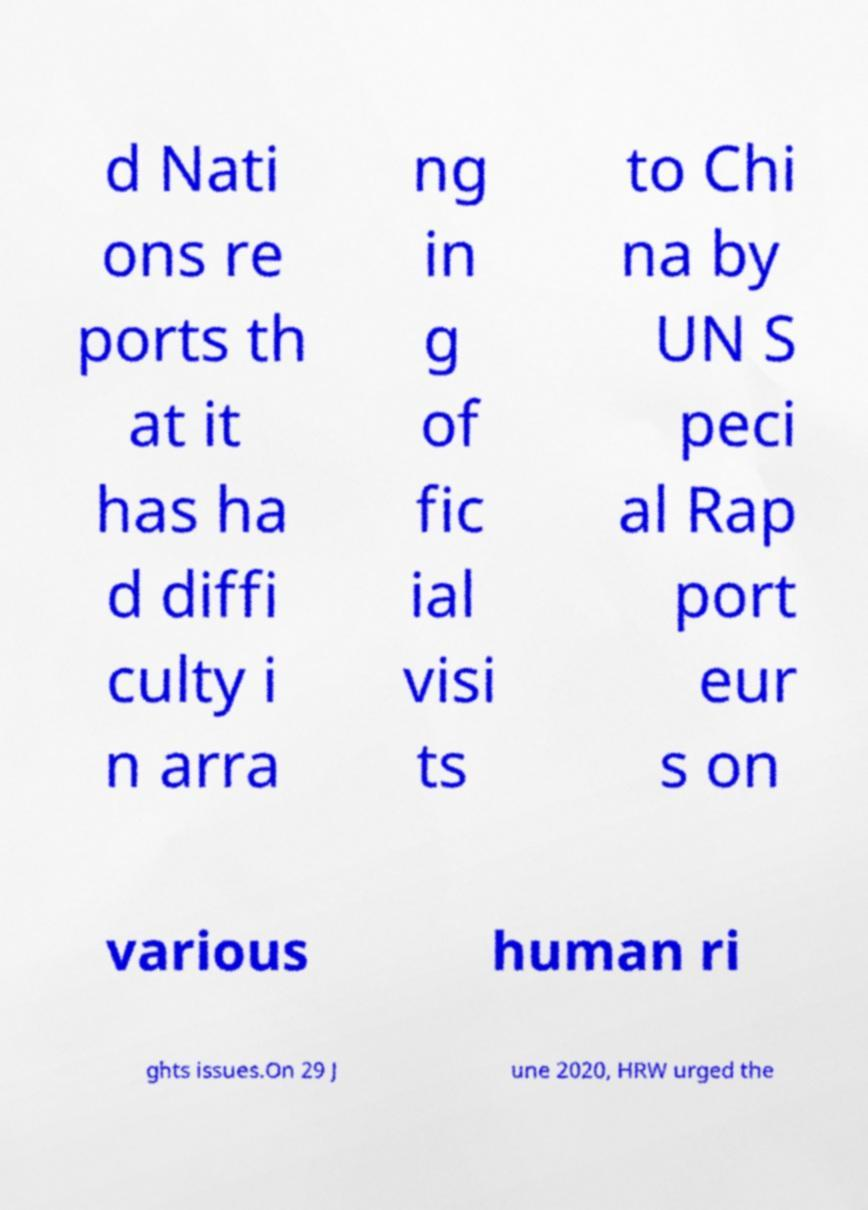I need the written content from this picture converted into text. Can you do that? d Nati ons re ports th at it has ha d diffi culty i n arra ng in g of fic ial visi ts to Chi na by UN S peci al Rap port eur s on various human ri ghts issues.On 29 J une 2020, HRW urged the 